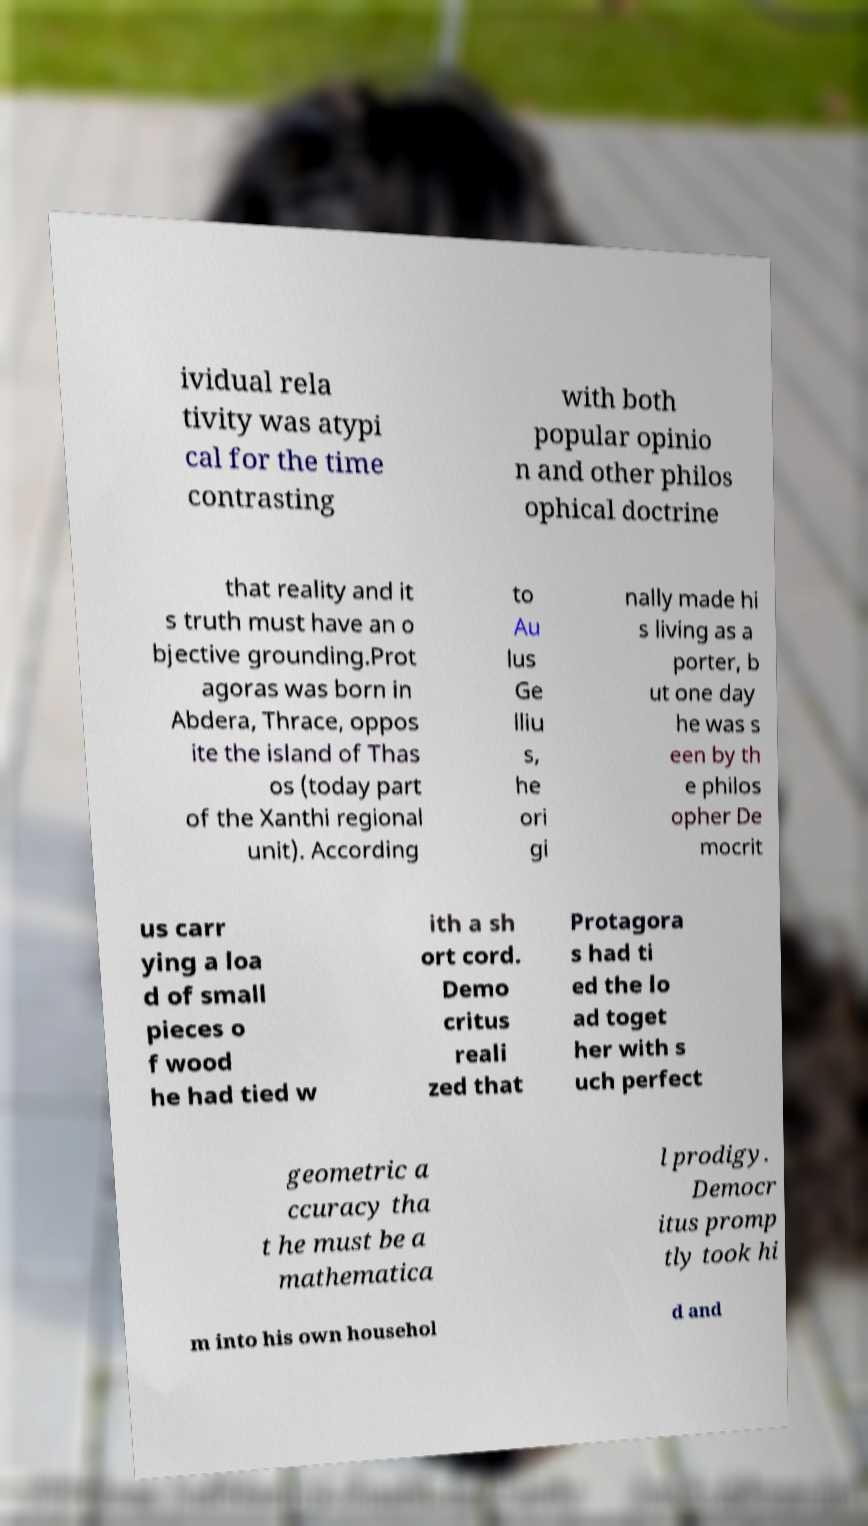Could you extract and type out the text from this image? ividual rela tivity was atypi cal for the time contrasting with both popular opinio n and other philos ophical doctrine that reality and it s truth must have an o bjective grounding.Prot agoras was born in Abdera, Thrace, oppos ite the island of Thas os (today part of the Xanthi regional unit). According to Au lus Ge lliu s, he ori gi nally made hi s living as a porter, b ut one day he was s een by th e philos opher De mocrit us carr ying a loa d of small pieces o f wood he had tied w ith a sh ort cord. Demo critus reali zed that Protagora s had ti ed the lo ad toget her with s uch perfect geometric a ccuracy tha t he must be a mathematica l prodigy. Democr itus promp tly took hi m into his own househol d and 